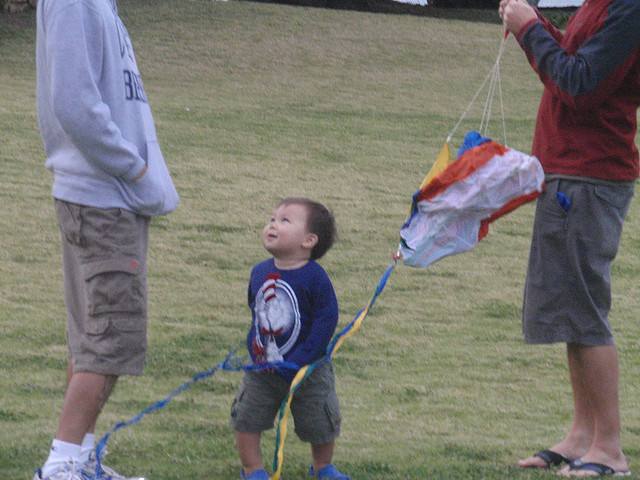<image>How many adults are present? I don't know exactly, but mostly possibility the number of adults present is 2. How many adults are present? I don't know how many adults are present. 